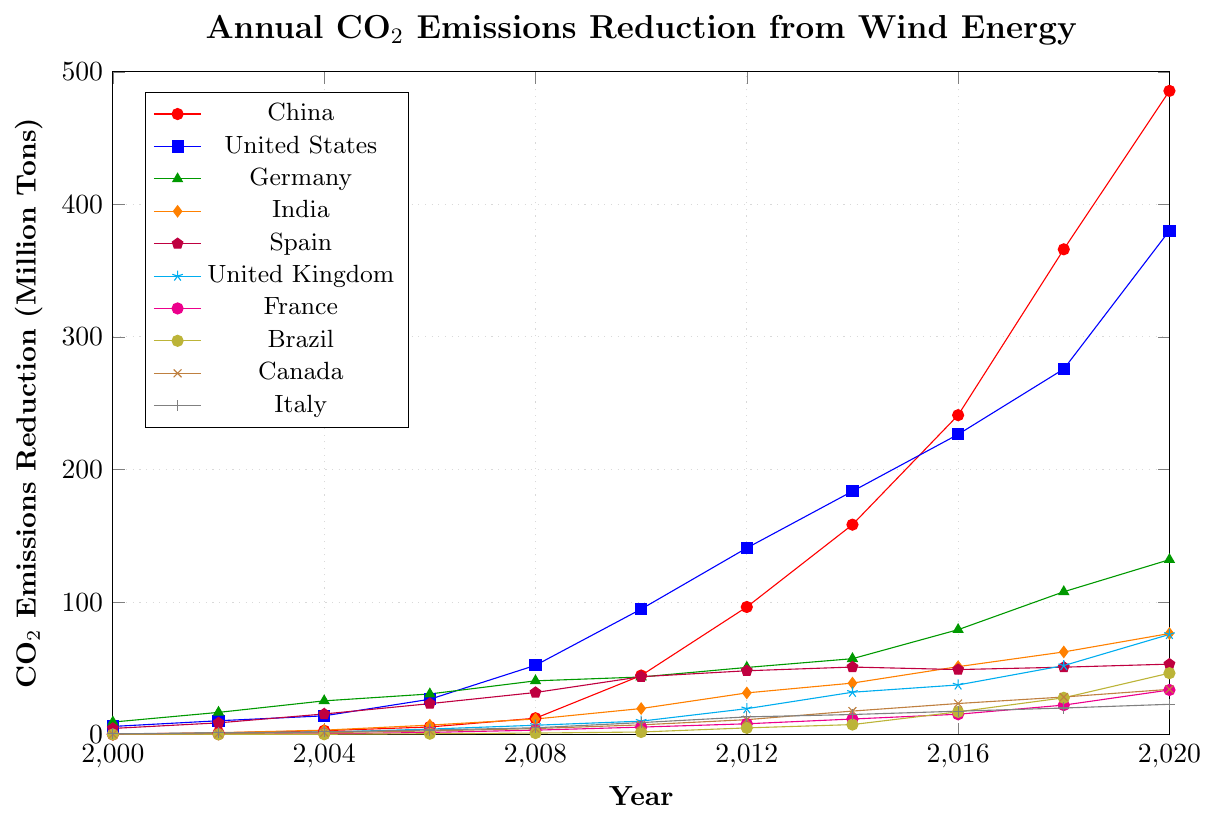Which country had the highest CO2 emission reduction in 2020? By looking at the data points for the year 2020 across all countries, it is evident that China had the highest CO2 emission reduction at approximately 485.6 million tons.
Answer: China How did the CO2 emission reduction in Brazil change from 2008 to 2020? To determine the change, subtract the 2008 value from the 2020 value for Brazil. The values are 46.4 (2020) and 1.2 (2008). So, 46.4 - 1.2 = 45.2.
Answer: Increased by 45.2 million tons Which countries showed a CO2 emission reduction of over 100 million tons by 2020? By examining the data points for 2020, China (485.6), United States (380.2), and Germany (132.0) each showed a CO2 emission reduction exceeding 100 million tons.
Answer: China, United States, Germany Between Germany and the United Kingdom, which country showed a greater increase in CO2 emission reduction from 2010 to 2020? Calculate the difference for both countries between 2010 and 2020. For Germany, it is 132.0 - 43.5 = 88.5. For the United Kingdom, it is 75.6 - 10.2 = 65.4. Comparing these values, Germany had a greater increase.
Answer: Germany What was the average CO2 emission reduction for Spain from 2000 to 2020? To find the average, sum all the data points for Spain from 2000 to 2020 and divide by the number of years (11). The values are summed as 4.7 + 8.9 + 15.6 + 23.4 + 31.8 + 43.7 + 48.2 + 51.0 + 49.1 + 50.9 + 53.2 = 380.5. The average is 380.5 / 11.
Answer: 34.6 million tons By how much did India's CO2 emission reduction grow from 2004 to 2018? Subtract the 2004 value from the 2018 value for India. The values are 62.4 (2018) and 3.4 (2004). So, 62.4 - 3.4 = 59.
Answer: 59 million tons Did any country show a decrease in CO2 emission reduction between any two consecutive data points? Looking at the data for each country year by year, Spain is the only country where a reduction can be observed between 2014 and 2016 (51.0 in 2014 to 49.1 in 2016).
Answer: Yes, Spain between 2014 and 2016 Which country experienced the most consistent growth in CO2 emissions reduction and how can you tell? France steadily increases year-on-year without any dips, indicating the most consistent growth pattern compared to other countries.
Answer: France How many countries surpassed the 20 million tons reduction mark by 2018? By examining the 2018 values, the countries surpassing 20 million tons are China, United States, Germany, India, United Kingdom, France, Brazil, and Canada, totaling 8 countries.
Answer: 8 countries What is the percentage growth in CO2 emission reduction for the United States from 2000 to 2020? First, calculate the difference between 2020 and 2000 values for the United States: 380.2 - 6.2 = 374. Next, divide this increase by the 2000 value and multiply by 100. So, (374 / 6.2) * 100 ≈ 6032.26%.
Answer: 6032.26% 